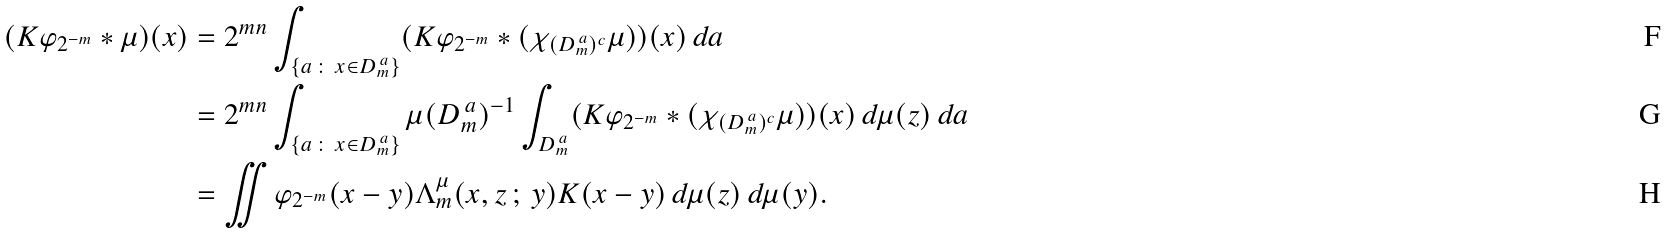<formula> <loc_0><loc_0><loc_500><loc_500>( K \varphi _ { 2 ^ { - m } } * \mu ) ( x ) & = 2 ^ { m n } \int _ { \{ a \, \colon \, x \in D ^ { \, a } _ { m } \} } ( K \varphi _ { 2 ^ { - m } } * ( \chi _ { ( D ^ { \, a } _ { m } ) ^ { c } } \mu ) ) ( x ) \, d a \\ & = 2 ^ { m n } \int _ { \{ a \, \colon \, x \in D ^ { \, a } _ { m } \} } \mu ( D ^ { \, a } _ { m } ) ^ { - 1 } \int _ { D ^ { \, a } _ { m } } ( K \varphi _ { 2 ^ { - m } } * ( \chi _ { ( D ^ { \, a } _ { m } ) ^ { c } } \mu ) ) ( x ) \, d \mu ( z ) \, d a \\ & = \iint \varphi _ { 2 ^ { - m } } ( x - y ) \Lambda ^ { \mu } _ { m } ( x , z \, ; \, y ) K ( x - y ) \, d \mu ( z ) \, d \mu ( y ) .</formula> 